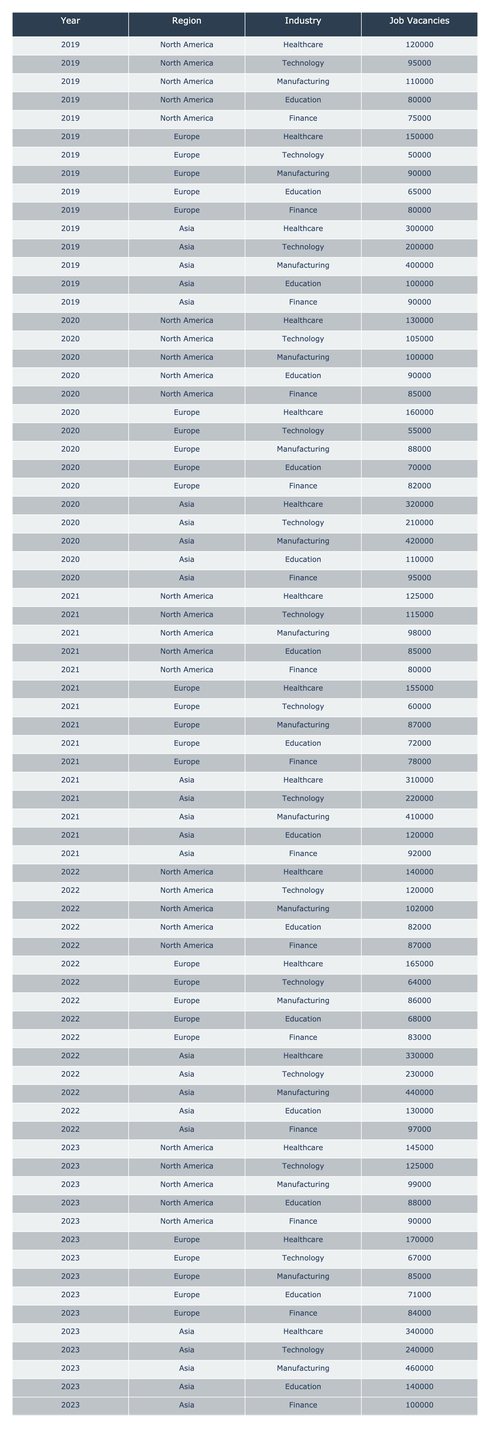What was the highest number of job vacancies in the healthcare industry in 2020? Referring to the table, the number of job vacancies in the healthcare industry for 2020 is 320,000, which is the highest figure presented for that year across all regions.
Answer: 320000 In what year did job vacancies in the technology industry in North America first exceed 100,000? Looking at the technology industry data in North America, in 2020 the vacancies were 105,000, which is the first instance they exceeded 100,000.
Answer: 2020 Which region had the most job vacancies in the manufacturing sector in 2023? In 2023, the manufacturing sector had 460,000 job vacancies in Asia, which is the highest compared to other regions.
Answer: Asia What was the average number of job vacancies in finance across all regions from 2019 to 2023? To find the average, we need to sum the job vacancies for finance from 2019 (75,000), 2020 (95,000), 2021 (92,000), 2022 (97,000), and 2023 (100,000), which totals 459,000. There are 5 years, so the average is 459,000 / 5 = 91,800.
Answer: 91800 Did the number of job vacancies in education decrease in Europe from 2019 to 2023? Reviewing the education sector data for Europe, the job vacancies were 65,000 in 2019, then fluctuated but ended up at 71,000 in 2023; hence it did not decrease.
Answer: No What was the total number of job vacancies in healthcare across all regions in 2021? From the table, in 2021 the job vacancies in healthcare were: North America (125,000), Europe (155,000), and Asia (310,000). The total is 125,000 + 155,000 + 310,000 = 590,000.
Answer: 590000 Which industry experienced the largest increase in job vacancies in North America from 2019 to 2023? Looking at North America, the job vacancies in healthcare increased from 120,000 in 2019 to 145,000 in 2023, an increase of 25,000, which is more than any other industry's increase over that period.
Answer: Healthcare In how many years did job vacancies in the technology industry in Asia exceed 200,000? Inspecting the table, the technology industry in Asia surpassed 200,000 in the years 2019, 2020, 2021, 2022, and 2023, which totals 5 years.
Answer: 5 What was the year-on-year growth rate for job vacancies in the finance sector in Europe from 2020 to 2021? In 2020, the finance vacancies were 82,000 and in 2021 they were 78,000. The growth rate is calculated as (78,000 - 82,000)/82,000 * 100%, that’s approximately -4.88%.
Answer: -4.88% Did job vacancies in education show overall growth in Asia from 2019 to 2023? Analyzing the education sector in Asia, the vacancies were 100,000 in 2019, increasing to 140,000 in 2023, showing a growth trend overall.
Answer: Yes What was the difference in job vacancies between the healthcare sector in Europe and North America in 2022? In 2022, the healthcare vacancies were 165,000 in Europe and 140,000 in North America. The difference is 165,000 - 140,000 = 25,000.
Answer: 25000 